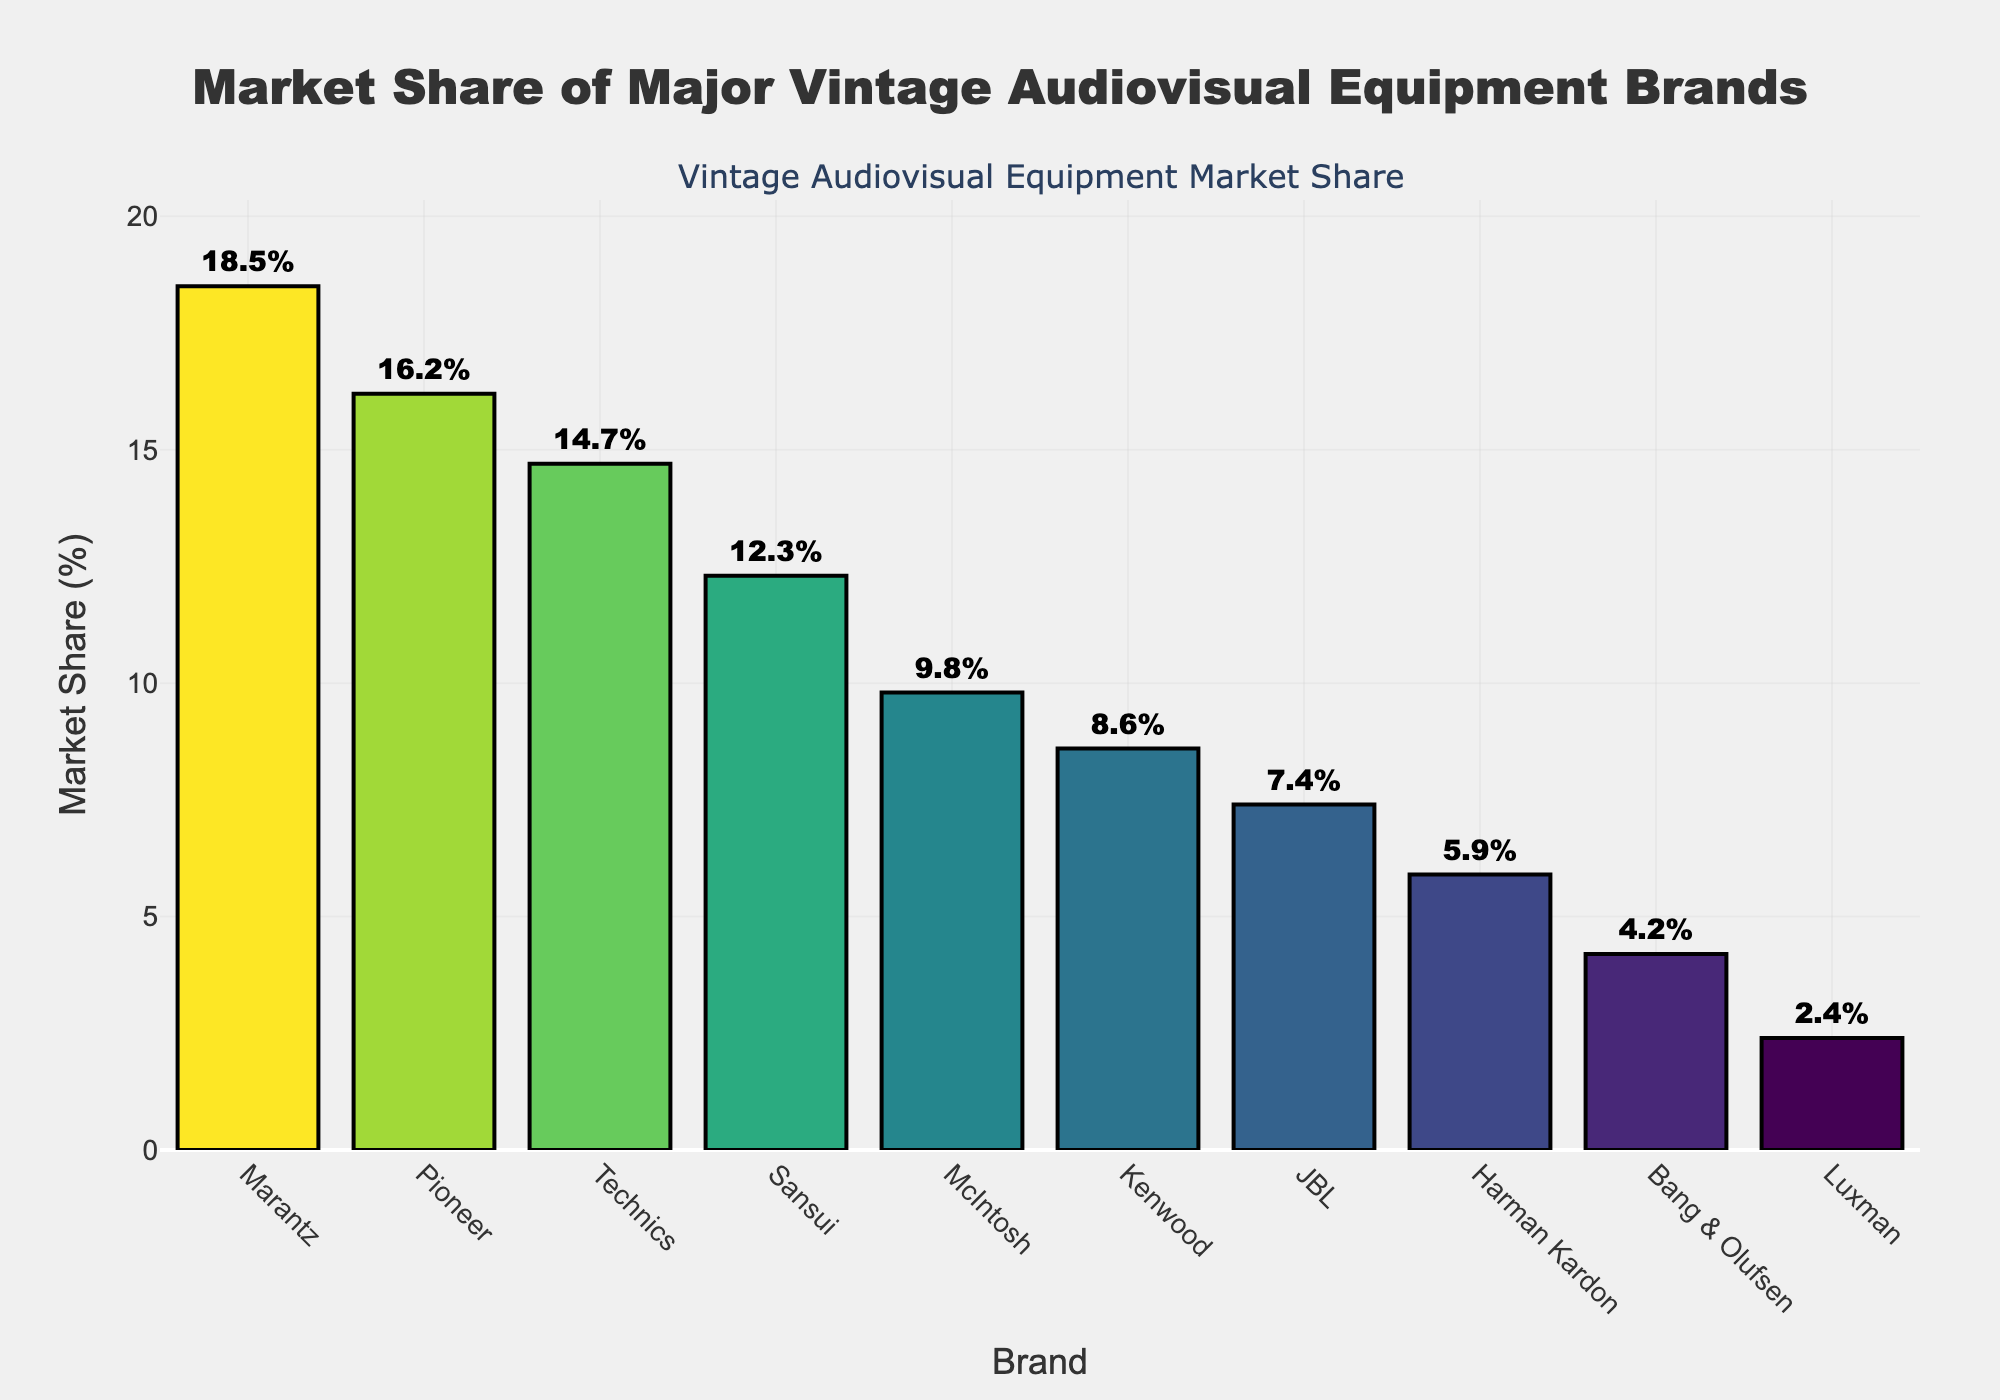What brand has the highest market share? By examining the bar chart, we can see that the tallest bar represents Marantz, indicating it has the highest market share among the brands listed.
Answer: Marantz Which two brands combined have a market share higher than Pioneer but less than Marantz? Marantz has a market share of 18.5%, and Pioneer has 16.2%. By inspecting the chart, we find that Technics (14.7%) and Sansui (12.3%) combined have a market share of 27%, which is greater than Pioneer's but less than Marantz's.
Answer: Technics and Sansui How much greater is the market share of Marantz compared to McIntosh? According to the bar chart, Marantz's market share is 18.5%, and McIntosh's is 9.8%. The difference is 18.5% - 9.8% = 8.7%.
Answer: 8.7% What is the average market share of the bottom three brands? The market shares of the bottom three brands (Harman Kardon, Bang & Olufsen, Luxman) are 5.9%, 4.2%, and 2.4%. The sum is 5.9 + 4.2 + 2.4 = 12.5%, and the average is 12.5% / 3 ≈ 4.17%.
Answer: 4.17% Which brand has a market share just below 10%? The bar just below the 10% mark represents McIntosh, which has a market share of 9.8%.
Answer: McIntosh Which two brands have a market share closest to each other, and what are their respective shares? By examining the bars closely, we can see that JBL and Harman Kardon have market shares of 7.4% and 5.9%, respectively. The difference is minimal compared to other brands.
Answer: JBL (7.4%) and Harman Kardon (5.9%) What is the total market share of all brands shown in the chart? To find the total market share, we sum the percentages of all brands: 18.5 + 16.2 + 14.7 + 12.3 + 9.8 + 8.6 + 7.4 + 5.9 + 4.2 + 2.4 = 100%.
Answer: 100% Rank the top three brands in descending order of their market share. By looking at the bar chart, the top three brands in descending order are Marantz (18.5%), Pioneer (16.2%), and Technics (14.7%).
Answer: Marantz, Pioneer, Technics 